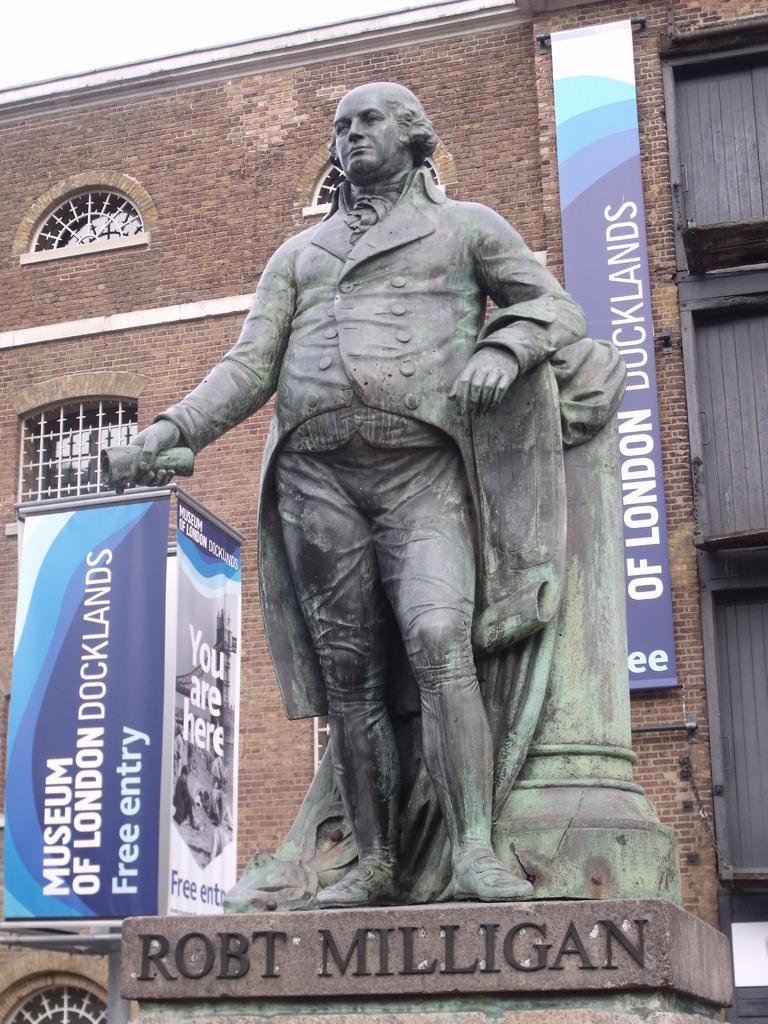Describe this image in one or two sentences. This is sculpture, this is building with the windows, these are banners. 